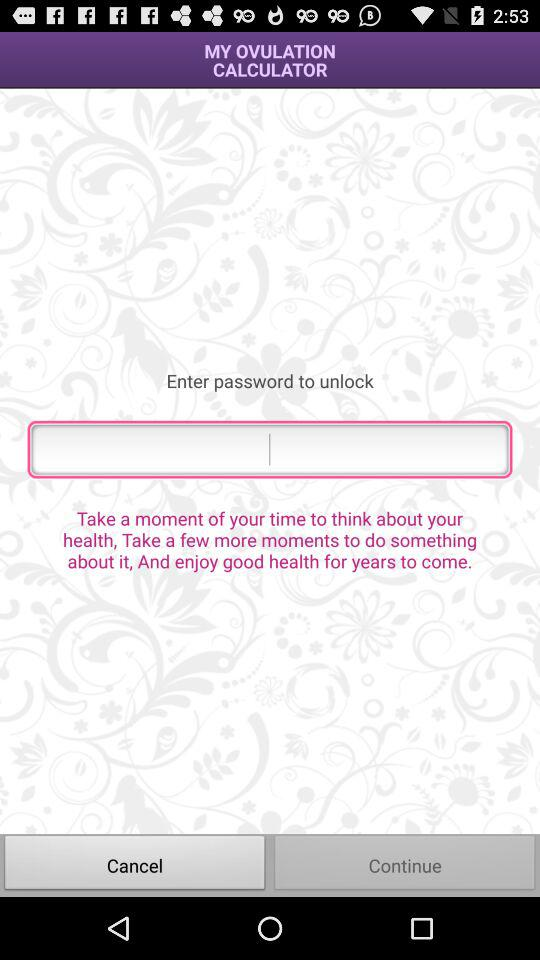What is the name of the application? The name of the application is "MY OVULATION CALCULATOR". 